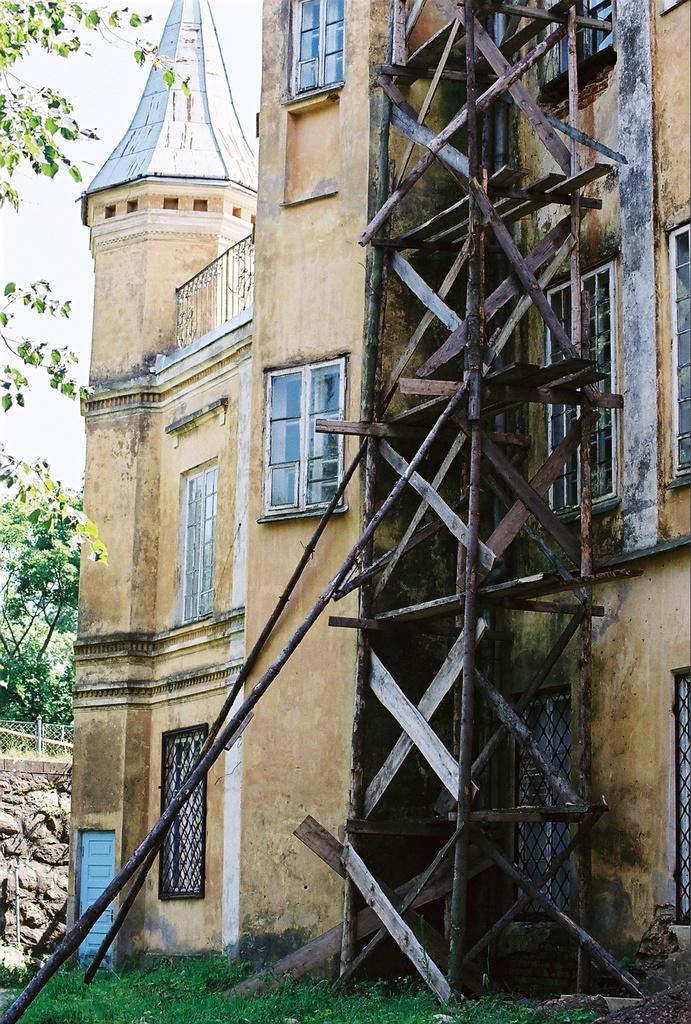What type of structure is visible in the image? There is a building in the image. What material is used for the windows of the building? The building has glass windows. What is placed in front of the building? There are wooden logs in front of the building. What can be seen in the background of the image? There is a fencing and trees in the background of the image. How would you describe the color of the sky in the image? The sky appears to be white in color. What type of religious symbol can be seen on the building in the image? There is no religious symbol visible on the building in the image. What type of metal is used for the fencing in the background? The fencing in the background is not described as being made of metal; it is simply mentioned as being present. 